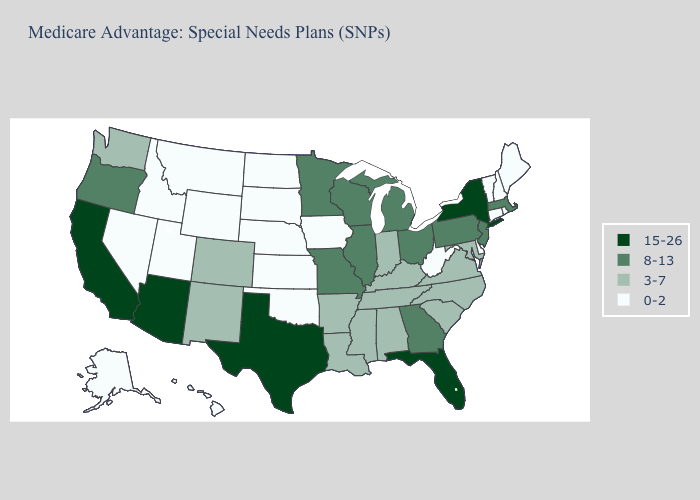How many symbols are there in the legend?
Be succinct. 4. Does Illinois have the lowest value in the USA?
Concise answer only. No. What is the value of Wisconsin?
Keep it brief. 8-13. Does Ohio have the highest value in the MidWest?
Concise answer only. Yes. What is the value of Maine?
Keep it brief. 0-2. Name the states that have a value in the range 15-26?
Concise answer only. Arizona, California, Florida, New York, Texas. Which states have the highest value in the USA?
Quick response, please. Arizona, California, Florida, New York, Texas. Is the legend a continuous bar?
Answer briefly. No. What is the value of Kentucky?
Quick response, please. 3-7. Among the states that border Iowa , which have the highest value?
Be succinct. Illinois, Minnesota, Missouri, Wisconsin. Which states hav the highest value in the South?
Concise answer only. Florida, Texas. Does Missouri have the same value as Texas?
Write a very short answer. No. Name the states that have a value in the range 8-13?
Short answer required. Georgia, Illinois, Massachusetts, Michigan, Minnesota, Missouri, New Jersey, Ohio, Oregon, Pennsylvania, Wisconsin. What is the value of Michigan?
Write a very short answer. 8-13. What is the value of Vermont?
Keep it brief. 0-2. 